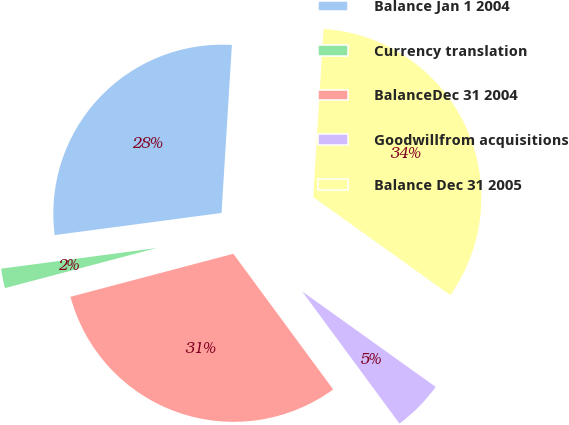<chart> <loc_0><loc_0><loc_500><loc_500><pie_chart><fcel>Balance Jan 1 2004<fcel>Currency translation<fcel>BalanceDec 31 2004<fcel>Goodwillfrom acquisitions<fcel>Balance Dec 31 2005<nl><fcel>28.08%<fcel>2.01%<fcel>30.99%<fcel>5.02%<fcel>33.9%<nl></chart> 